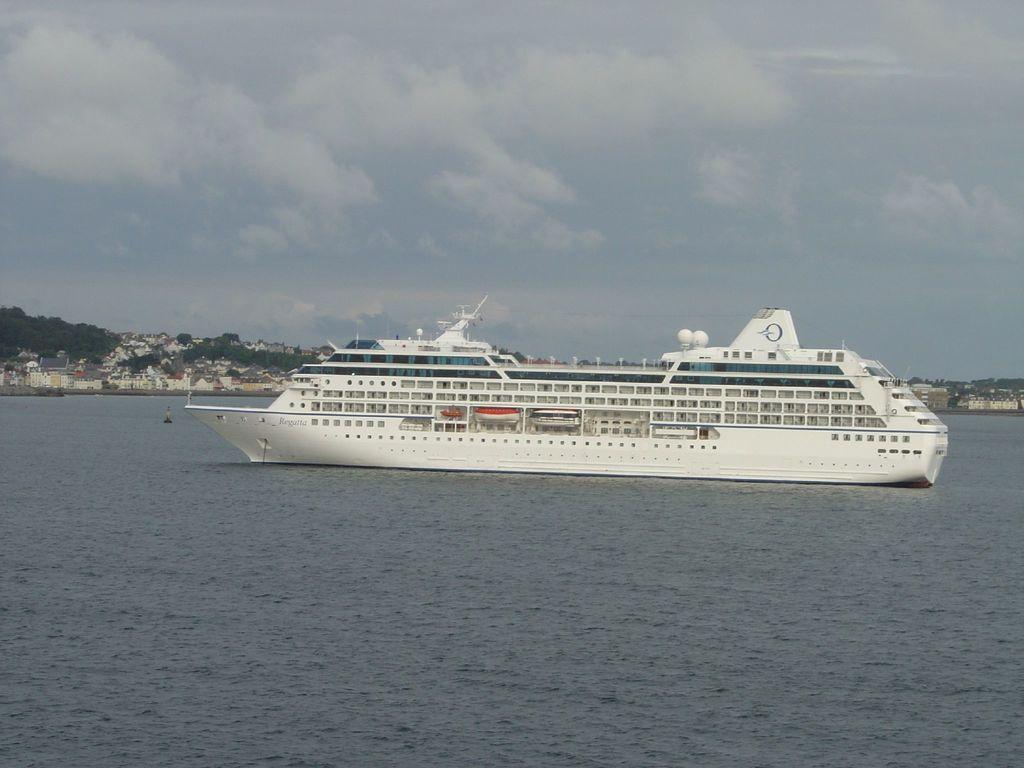Could you give a brief overview of what you see in this image? In the foreground of this image, there is a ship on the water. In the background, there are buildings, trees, sky and the cloud. 